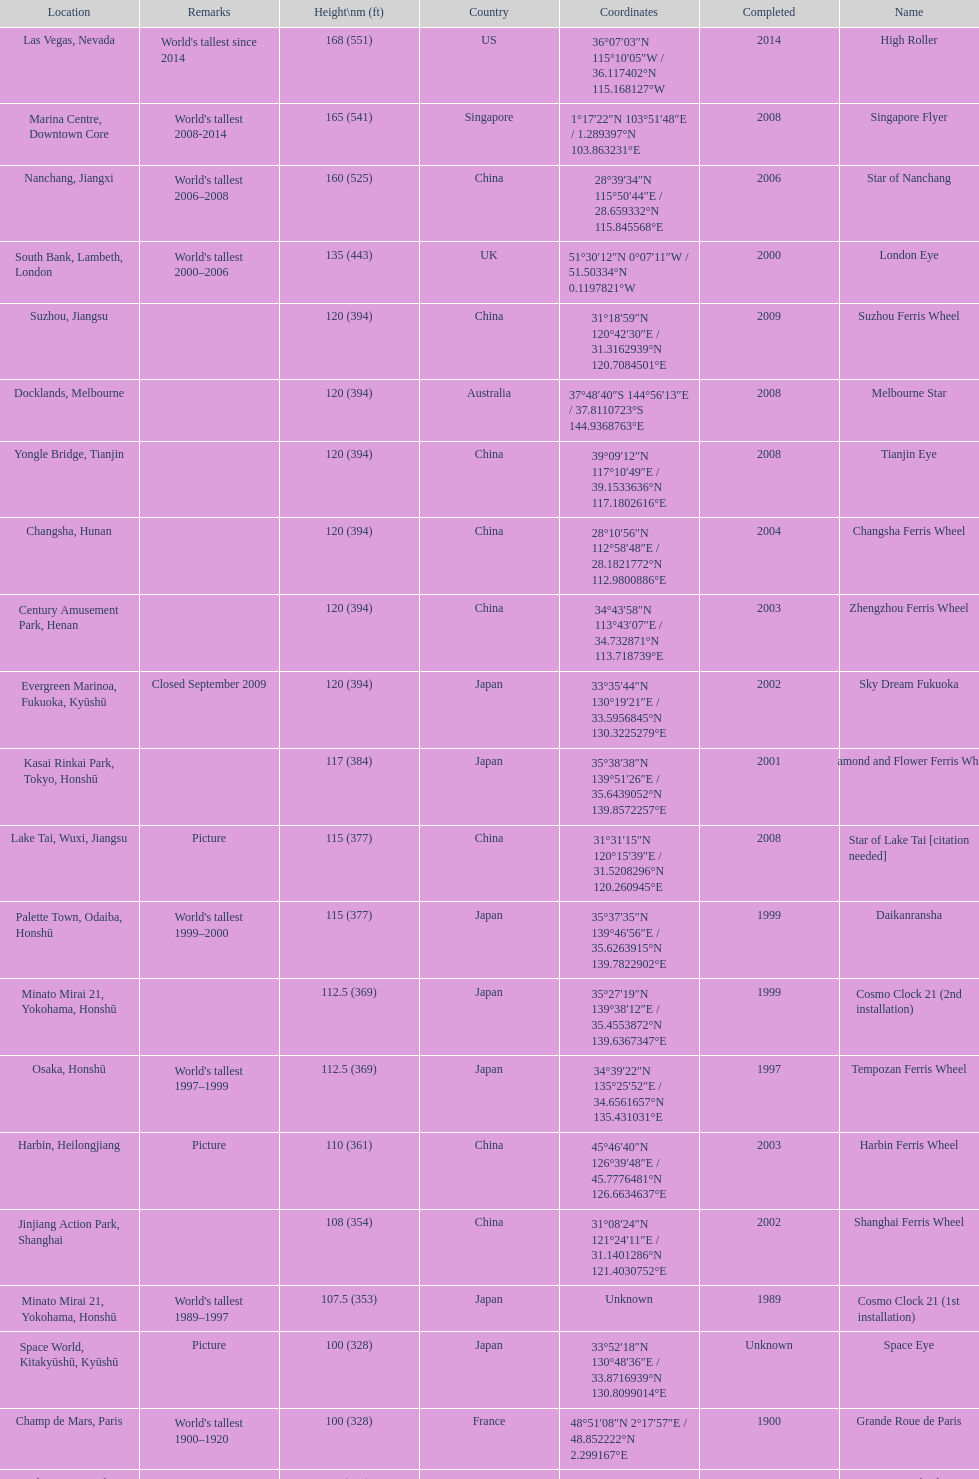Which ferris wheel was completed in 2008 and has the height of 165? Singapore Flyer. 